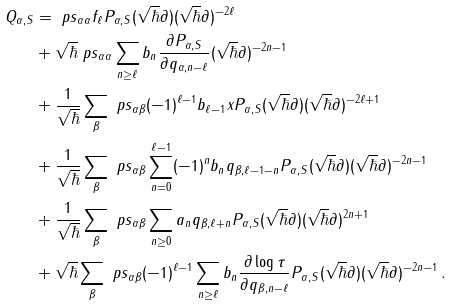Convert formula to latex. <formula><loc_0><loc_0><loc_500><loc_500>Q _ { \alpha , S } & = \ p s _ { \alpha \alpha } f _ { \ell } P _ { \alpha , S } ( \sqrt { \hbar } \partial ) ( \sqrt { \hbar } \partial ) ^ { - 2 \ell } \\ & + { \sqrt { \hbar } } \ p s _ { \alpha \alpha } \sum _ { n \geq \ell } b _ { n } \frac { \partial P _ { \alpha , S } } { \partial q _ { \alpha , n - \ell } } ( \sqrt { \hbar } \partial ) ^ { - 2 n - 1 } \\ & + \frac { 1 } { \sqrt { \hbar } } \sum _ { \beta } \ p s _ { \alpha \beta } ( - 1 ) ^ { \ell - 1 } b _ { \ell - 1 } x P _ { \alpha , S } ( \sqrt { \hbar } \partial ) ( \sqrt { \hbar } \partial ) ^ { - 2 \ell + 1 } \\ & + \frac { 1 } { \sqrt { \hbar } } \sum _ { \beta } \ p s _ { \alpha \beta } \sum _ { n = 0 } ^ { \ell - 1 } ( - 1 ) ^ { n } b _ { n } q _ { \beta , \ell - 1 - n } P _ { \alpha , S } ( \sqrt { \hbar } \partial ) ( \sqrt { \hbar } \partial ) ^ { - 2 n - 1 } \\ & + \frac { 1 } { \sqrt { \hbar } } \sum _ { \beta } \ p s _ { \alpha \beta } \sum _ { n \geq 0 } a _ { n } q _ { \beta , \ell + n } P _ { \alpha , S } ( \sqrt { \hbar } \partial ) ( \sqrt { \hbar } \partial ) ^ { 2 n + 1 } \\ & + { \sqrt { \hbar } } \sum _ { \beta } \ p s _ { \alpha \beta } ( - 1 ) ^ { \ell - 1 } \sum _ { n \geq \ell } b _ { n } \frac { \partial \log \tau } { \partial q _ { \beta , n - \ell } } P _ { \alpha , S } ( \sqrt { \hbar } \partial ) ( \sqrt { \hbar } \partial ) ^ { - 2 n - 1 } \, .</formula> 